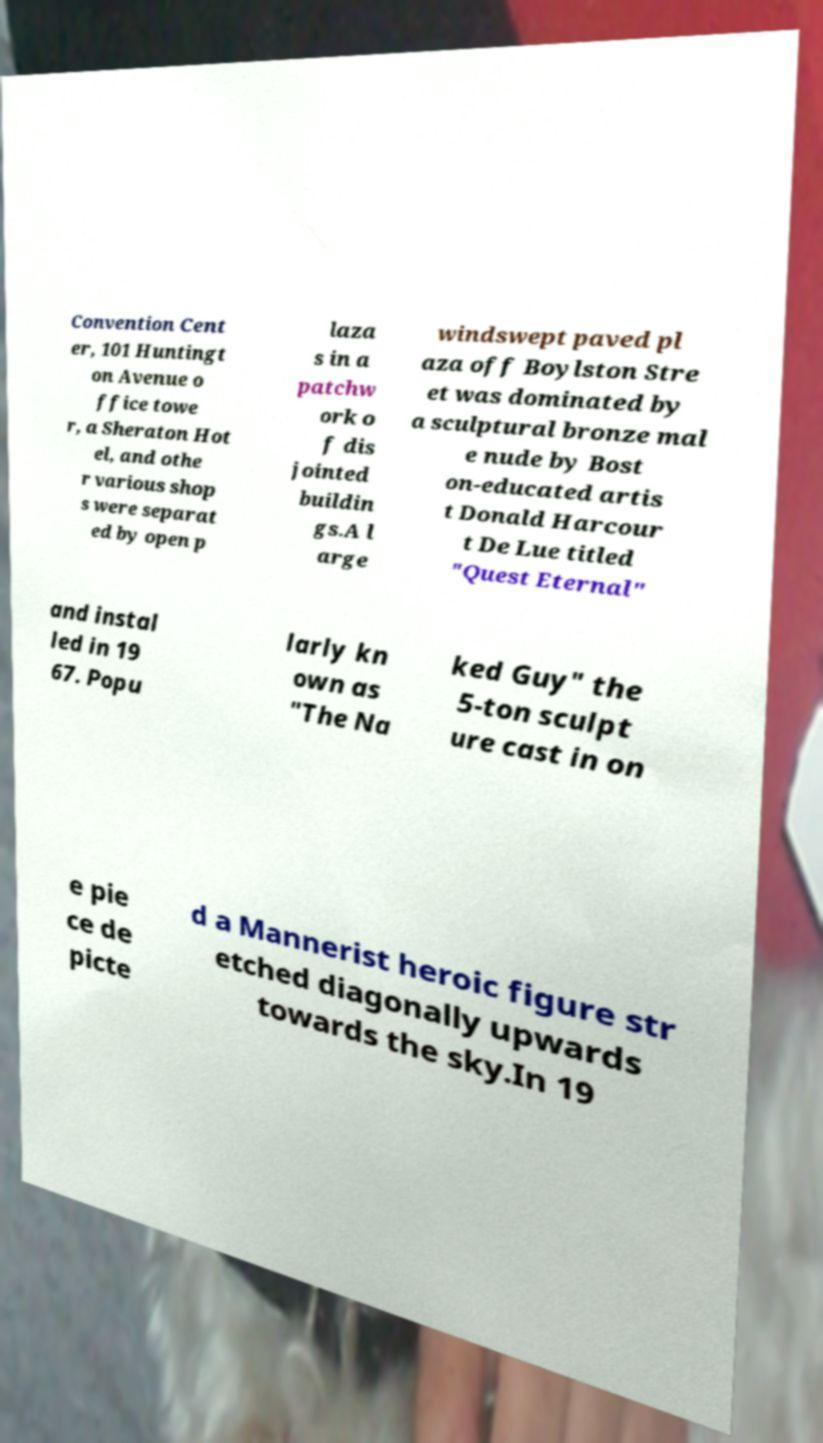Can you read and provide the text displayed in the image?This photo seems to have some interesting text. Can you extract and type it out for me? Convention Cent er, 101 Huntingt on Avenue o ffice towe r, a Sheraton Hot el, and othe r various shop s were separat ed by open p laza s in a patchw ork o f dis jointed buildin gs.A l arge windswept paved pl aza off Boylston Stre et was dominated by a sculptural bronze mal e nude by Bost on-educated artis t Donald Harcour t De Lue titled "Quest Eternal" and instal led in 19 67. Popu larly kn own as "The Na ked Guy" the 5-ton sculpt ure cast in on e pie ce de picte d a Mannerist heroic figure str etched diagonally upwards towards the sky.In 19 